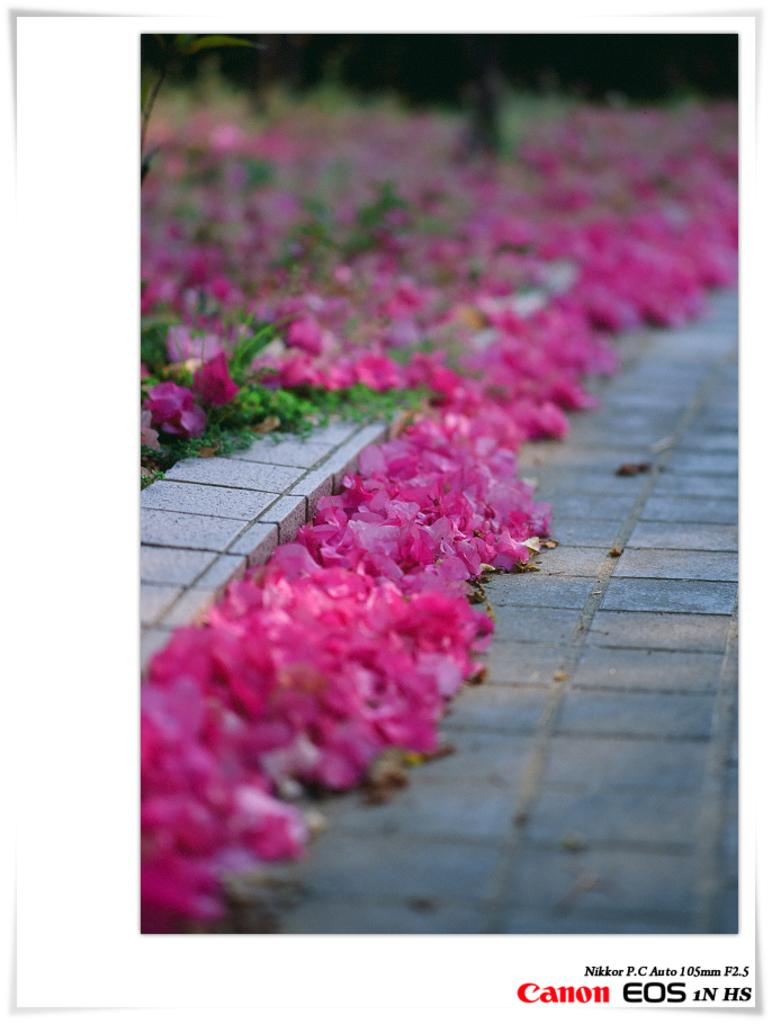What is depicted on the paper in the image? There is a photo on the paper in the image. What can be seen in the photo? The photo contains flowers and leaves. Is there any text visible in the image? Yes, there is text in the bottom right corner of the image. What type of wine is being served in the image? There is no wine present in the image; it features a photo of flowers and leaves with text in the bottom right corner. How does the friction affect the profit in the image? There is no mention of friction or profit in the image, as it only contains a photo of flowers and leaves with text in the bottom right corner. 